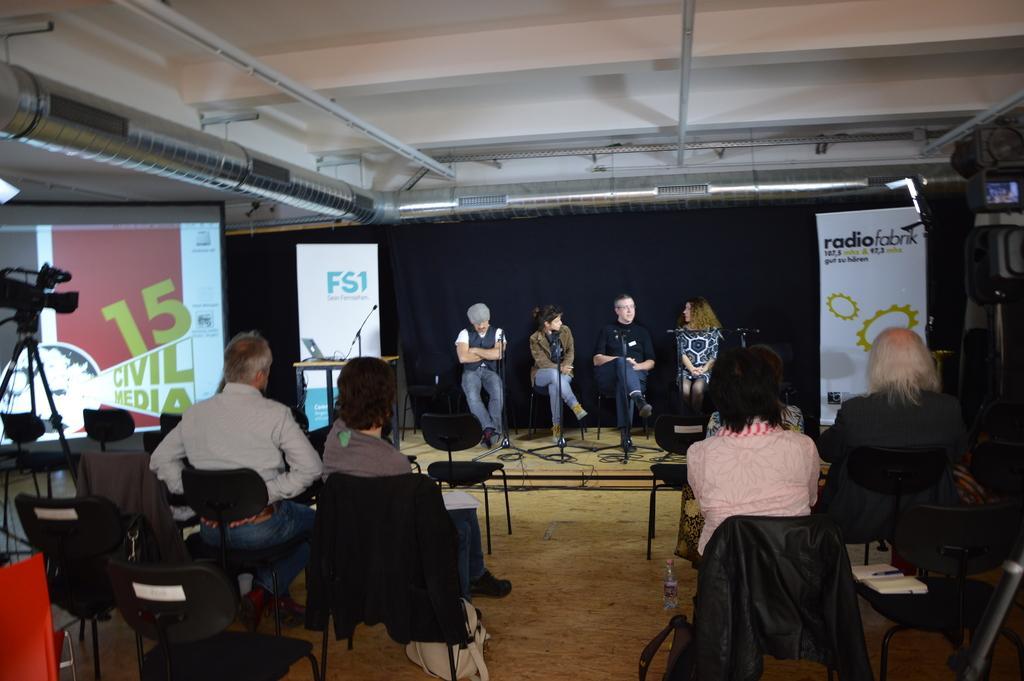Can you describe this image briefly? In this image there are some people sitting on the chairs behind them there are some banners and curtain, also there are another group of people sitting in front of them and there is a camera on the stand. 